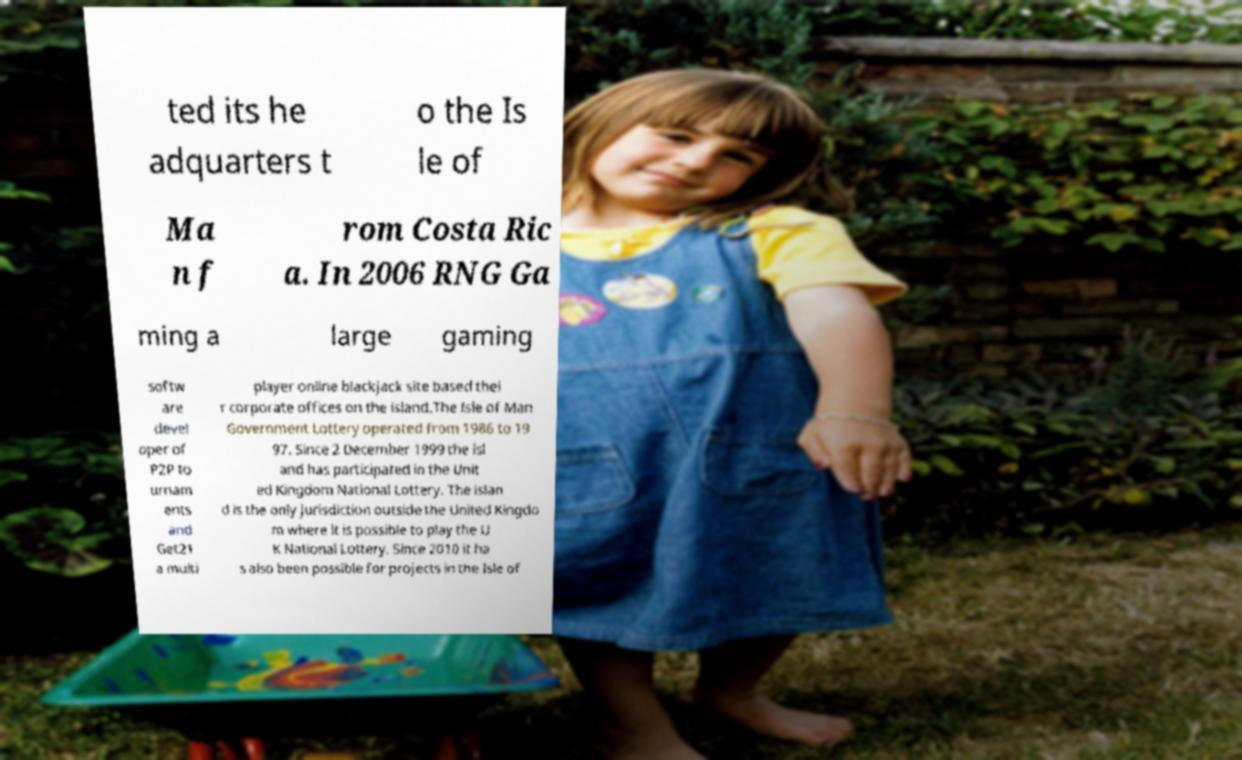I need the written content from this picture converted into text. Can you do that? ted its he adquarters t o the Is le of Ma n f rom Costa Ric a. In 2006 RNG Ga ming a large gaming softw are devel oper of P2P to urnam ents and Get21 a multi player online blackjack site based thei r corporate offices on the island.The Isle of Man Government Lottery operated from 1986 to 19 97. Since 2 December 1999 the isl and has participated in the Unit ed Kingdom National Lottery. The islan d is the only jurisdiction outside the United Kingdo m where it is possible to play the U K National Lottery. Since 2010 it ha s also been possible for projects in the Isle of 